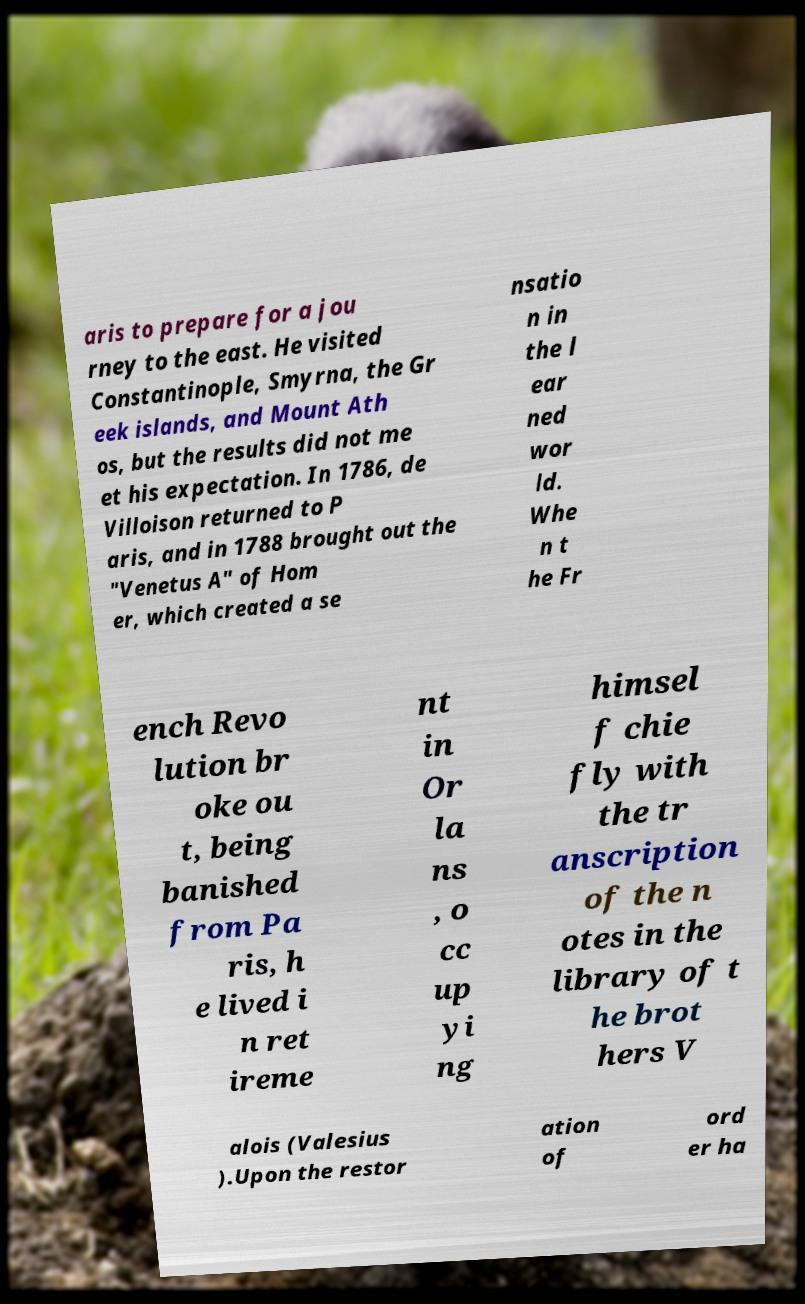Could you extract and type out the text from this image? aris to prepare for a jou rney to the east. He visited Constantinople, Smyrna, the Gr eek islands, and Mount Ath os, but the results did not me et his expectation. In 1786, de Villoison returned to P aris, and in 1788 brought out the "Venetus A" of Hom er, which created a se nsatio n in the l ear ned wor ld. Whe n t he Fr ench Revo lution br oke ou t, being banished from Pa ris, h e lived i n ret ireme nt in Or la ns , o cc up yi ng himsel f chie fly with the tr anscription of the n otes in the library of t he brot hers V alois (Valesius ).Upon the restor ation of ord er ha 